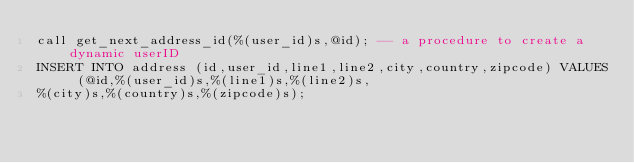<code> <loc_0><loc_0><loc_500><loc_500><_SQL_>call get_next_address_id(%(user_id)s,@id); -- a procedure to create a dynamic userID
INSERT INTO address (id,user_id,line1,line2,city,country,zipcode) VALUES (@id,%(user_id)s,%(line1)s,%(line2)s,
%(city)s,%(country)s,%(zipcode)s);</code> 